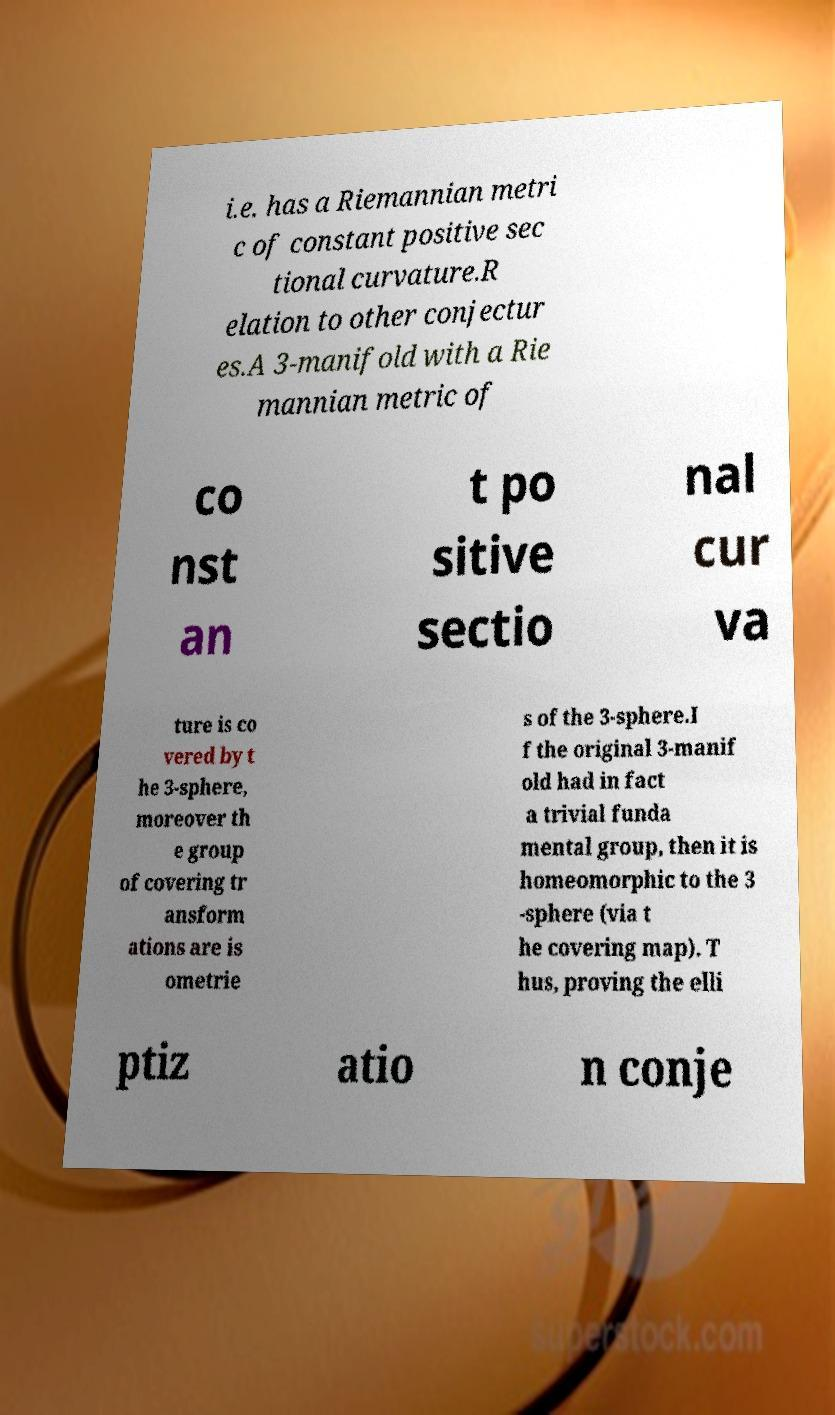What messages or text are displayed in this image? I need them in a readable, typed format. i.e. has a Riemannian metri c of constant positive sec tional curvature.R elation to other conjectur es.A 3-manifold with a Rie mannian metric of co nst an t po sitive sectio nal cur va ture is co vered by t he 3-sphere, moreover th e group of covering tr ansform ations are is ometrie s of the 3-sphere.I f the original 3-manif old had in fact a trivial funda mental group, then it is homeomorphic to the 3 -sphere (via t he covering map). T hus, proving the elli ptiz atio n conje 